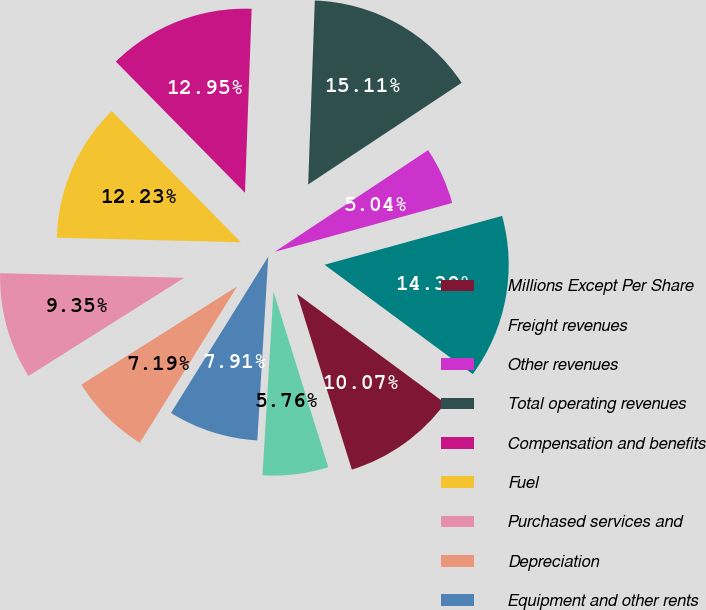<chart> <loc_0><loc_0><loc_500><loc_500><pie_chart><fcel>Millions Except Per Share<fcel>Freight revenues<fcel>Other revenues<fcel>Total operating revenues<fcel>Compensation and benefits<fcel>Fuel<fcel>Purchased services and<fcel>Depreciation<fcel>Equipment and other rents<fcel>Other<nl><fcel>10.07%<fcel>14.39%<fcel>5.04%<fcel>15.11%<fcel>12.95%<fcel>12.23%<fcel>9.35%<fcel>7.19%<fcel>7.91%<fcel>5.76%<nl></chart> 